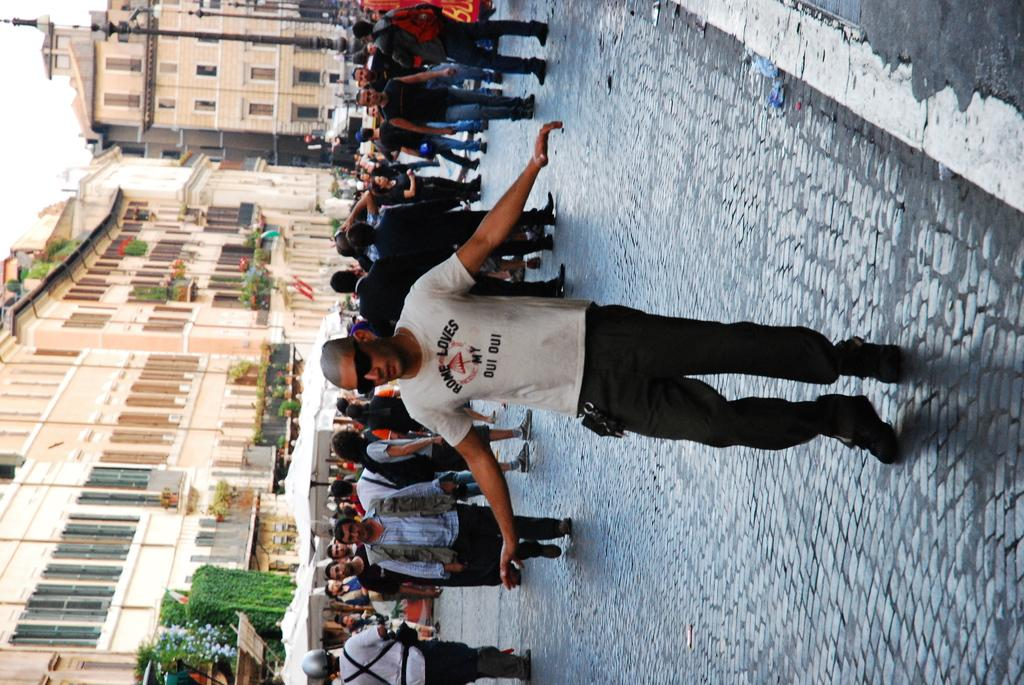How many people are present in the image? There are many people in the image. What are some of the people doing in the image? Some of the people are walking. What can be seen in the background of the image? There are buildings and the sky visible in the background of the image. What type of vegetation is at the bottom of the image? There are bushes at the bottom of the image. What type of cabbage can be seen growing in the rhythm of the rock in the image? There is no cabbage, rhythm, or rock present in the image. 